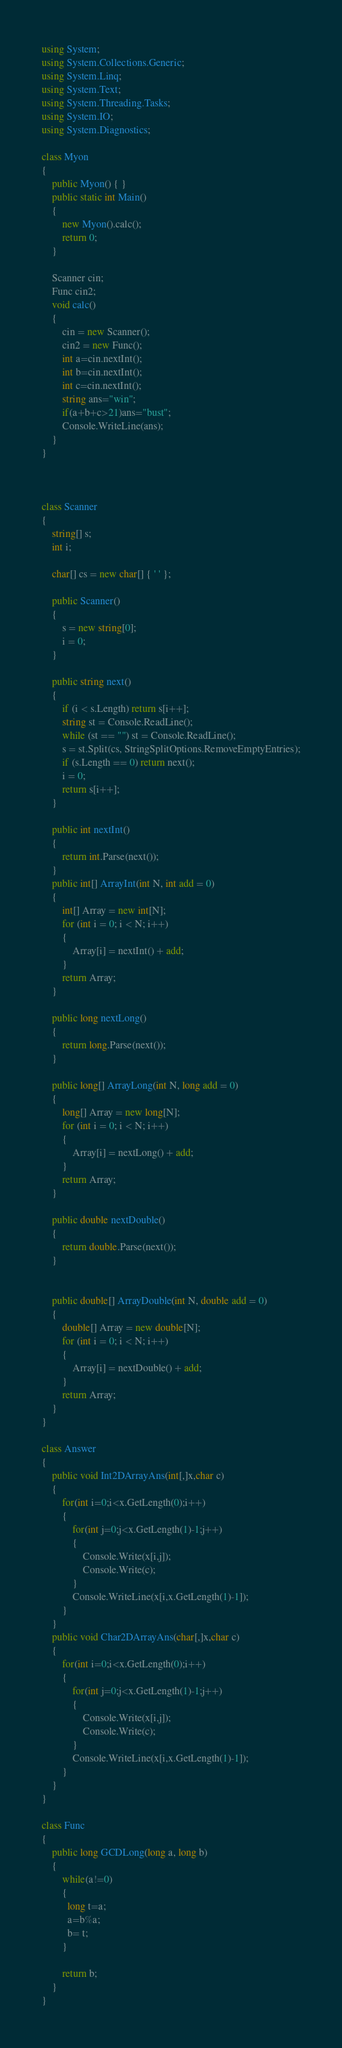Convert code to text. <code><loc_0><loc_0><loc_500><loc_500><_C#_>using System;
using System.Collections.Generic;
using System.Linq;
using System.Text;
using System.Threading.Tasks;
using System.IO;
using System.Diagnostics;

class Myon
{
    public Myon() { }
    public static int Main()
    {
        new Myon().calc();
        return 0;
    }

    Scanner cin;
    Func cin2;
    void calc()
    {
        cin = new Scanner();
        cin2 = new Func();
        int a=cin.nextInt();
        int b=cin.nextInt();
        int c=cin.nextInt();
        string ans="win";
        if(a+b+c>21)ans="bust";
        Console.WriteLine(ans);
    }
}



class Scanner
{
    string[] s;
    int i;

    char[] cs = new char[] { ' ' };

    public Scanner()
    {
        s = new string[0];
        i = 0;
    }

    public string next()
    {
        if (i < s.Length) return s[i++];
        string st = Console.ReadLine();
        while (st == "") st = Console.ReadLine();
        s = st.Split(cs, StringSplitOptions.RemoveEmptyEntries);
        if (s.Length == 0) return next();
        i = 0;
        return s[i++];
    }

    public int nextInt()
    {
        return int.Parse(next());
    }
    public int[] ArrayInt(int N, int add = 0)
    {
        int[] Array = new int[N];
        for (int i = 0; i < N; i++)
        {
            Array[i] = nextInt() + add;
        }
        return Array;
    }

    public long nextLong()
    {
        return long.Parse(next());
    }

    public long[] ArrayLong(int N, long add = 0)
    {
        long[] Array = new long[N];
        for (int i = 0; i < N; i++)
        {
            Array[i] = nextLong() + add;
        }
        return Array;
    }

    public double nextDouble()
    {
        return double.Parse(next());
    }


    public double[] ArrayDouble(int N, double add = 0)
    {
        double[] Array = new double[N];
        for (int i = 0; i < N; i++)
        {
            Array[i] = nextDouble() + add;
        }
        return Array;
    }
}

class Answer
{
    public void Int2DArrayAns(int[,]x,char c)
    {
        for(int i=0;i<x.GetLength(0);i++)
        {
            for(int j=0;j<x.GetLength(1)-1;j++)
            {
                Console.Write(x[i,j]);
                Console.Write(c);
            }
            Console.WriteLine(x[i,x.GetLength(1)-1]);
        }
    }
    public void Char2DArrayAns(char[,]x,char c)
    {
        for(int i=0;i<x.GetLength(0);i++)
        {
            for(int j=0;j<x.GetLength(1)-1;j++)
            {
                Console.Write(x[i,j]);
                Console.Write(c);
            }
            Console.WriteLine(x[i,x.GetLength(1)-1]);
        }
    }
}

class Func
{
    public long GCDLong(long a, long b)
    {
        while(a!=0)
        {
          long t=a;
          a=b%a;
          b= t;
        }
      
        return b;        
    }
}</code> 